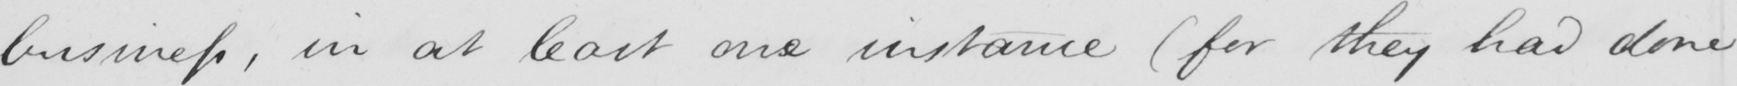What is written in this line of handwriting? business , in at least one instance  ( for they had done 